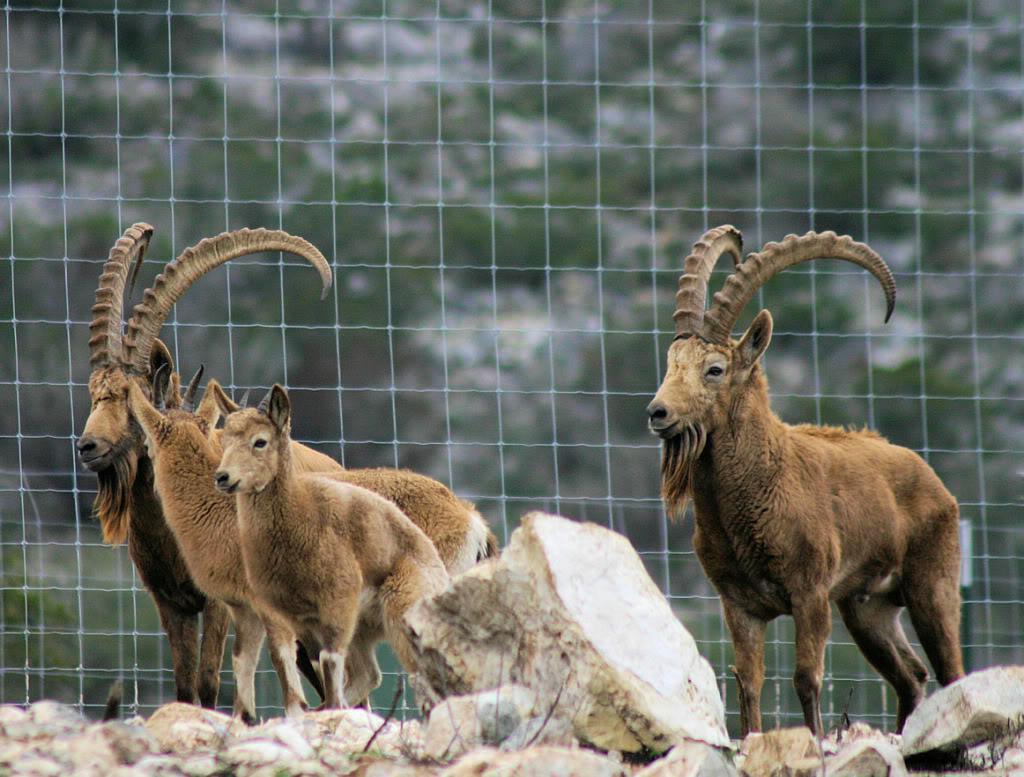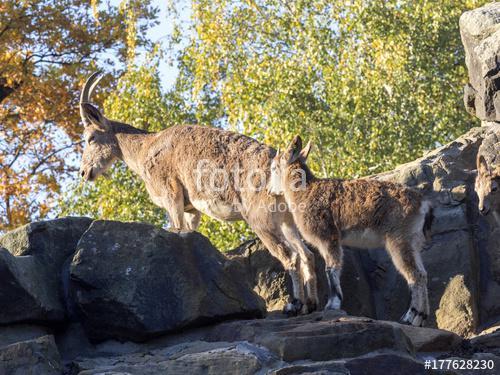The first image is the image on the left, the second image is the image on the right. Evaluate the accuracy of this statement regarding the images: "The left image shows at least one goat with very long horns on its head.". Is it true? Answer yes or no. Yes. The first image is the image on the left, the second image is the image on the right. Considering the images on both sides, is "Four or fewer goats are visible." valid? Answer yes or no. No. 